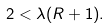<formula> <loc_0><loc_0><loc_500><loc_500>2 < \lambda ( R + 1 ) .</formula> 